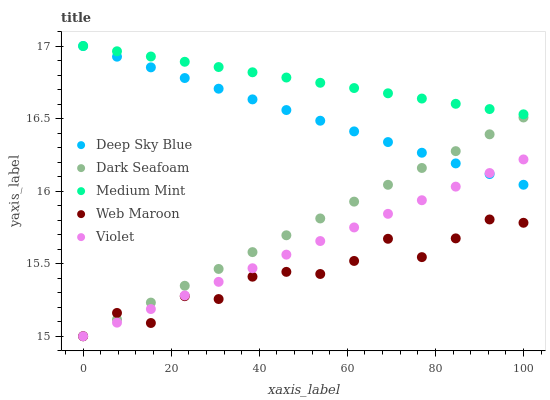Does Web Maroon have the minimum area under the curve?
Answer yes or no. Yes. Does Medium Mint have the maximum area under the curve?
Answer yes or no. Yes. Does Dark Seafoam have the minimum area under the curve?
Answer yes or no. No. Does Dark Seafoam have the maximum area under the curve?
Answer yes or no. No. Is Medium Mint the smoothest?
Answer yes or no. Yes. Is Web Maroon the roughest?
Answer yes or no. Yes. Is Dark Seafoam the smoothest?
Answer yes or no. No. Is Dark Seafoam the roughest?
Answer yes or no. No. Does Dark Seafoam have the lowest value?
Answer yes or no. Yes. Does Deep Sky Blue have the lowest value?
Answer yes or no. No. Does Deep Sky Blue have the highest value?
Answer yes or no. Yes. Does Dark Seafoam have the highest value?
Answer yes or no. No. Is Web Maroon less than Medium Mint?
Answer yes or no. Yes. Is Deep Sky Blue greater than Web Maroon?
Answer yes or no. Yes. Does Deep Sky Blue intersect Medium Mint?
Answer yes or no. Yes. Is Deep Sky Blue less than Medium Mint?
Answer yes or no. No. Is Deep Sky Blue greater than Medium Mint?
Answer yes or no. No. Does Web Maroon intersect Medium Mint?
Answer yes or no. No. 